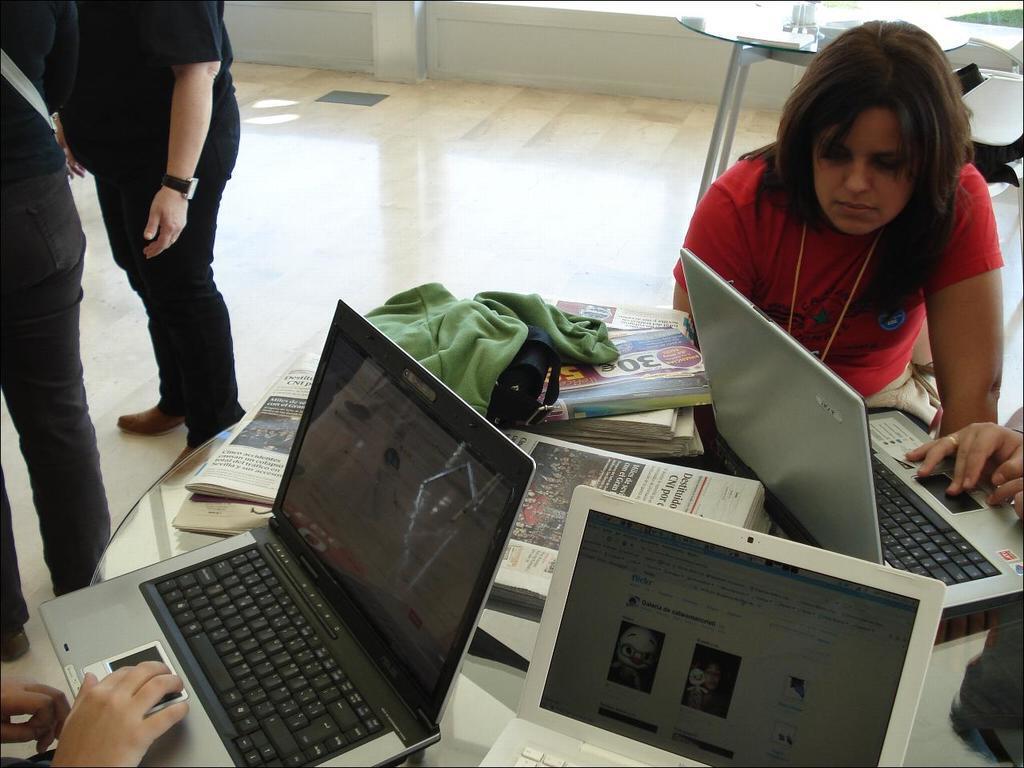Can you describe this image briefly? In the image there is a table and on the table there are three laptops,some books and papers and in front of the table some people are sitting and working and in the left side there are two people standing. Behind the first table there is another empty table. 